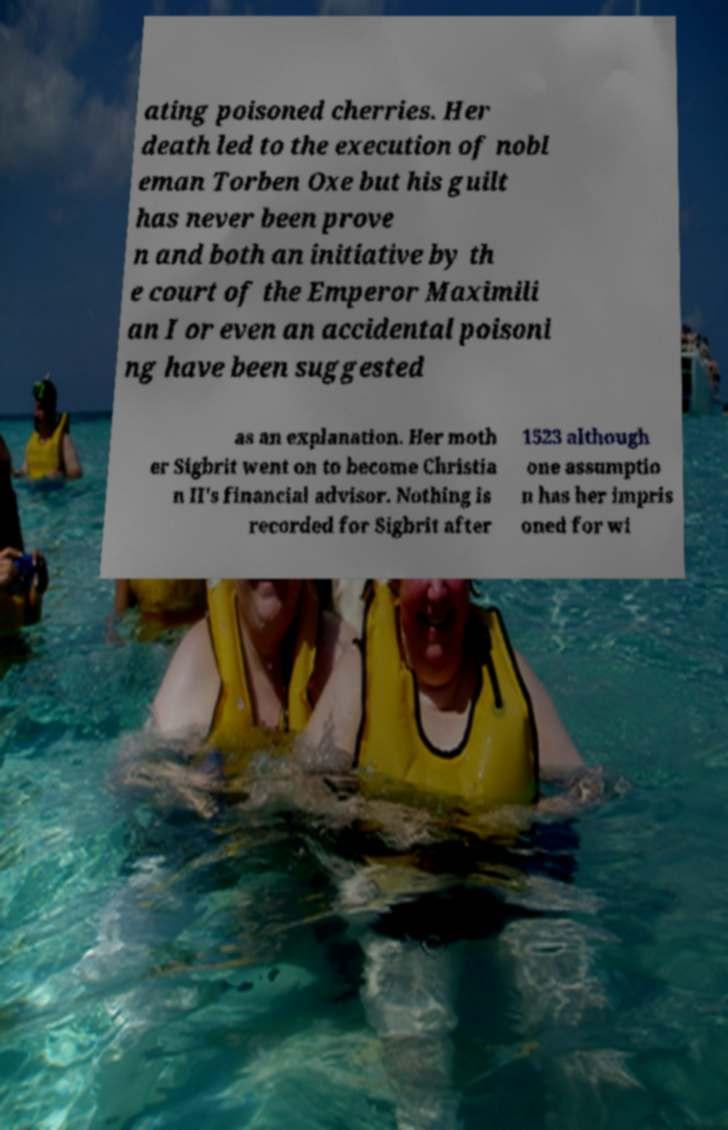Please read and relay the text visible in this image. What does it say? ating poisoned cherries. Her death led to the execution of nobl eman Torben Oxe but his guilt has never been prove n and both an initiative by th e court of the Emperor Maximili an I or even an accidental poisoni ng have been suggested as an explanation. Her moth er Sigbrit went on to become Christia n II's financial advisor. Nothing is recorded for Sigbrit after 1523 although one assumptio n has her impris oned for wi 